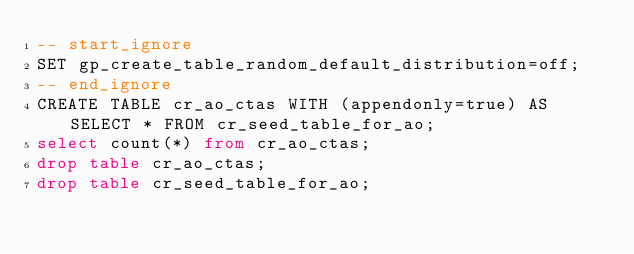Convert code to text. <code><loc_0><loc_0><loc_500><loc_500><_SQL_>-- start_ignore
SET gp_create_table_random_default_distribution=off;
-- end_ignore
CREATE TABLE cr_ao_ctas WITH (appendonly=true) AS SELECT * FROM cr_seed_table_for_ao;
select count(*) from cr_ao_ctas;
drop table cr_ao_ctas;
drop table cr_seed_table_for_ao;
</code> 